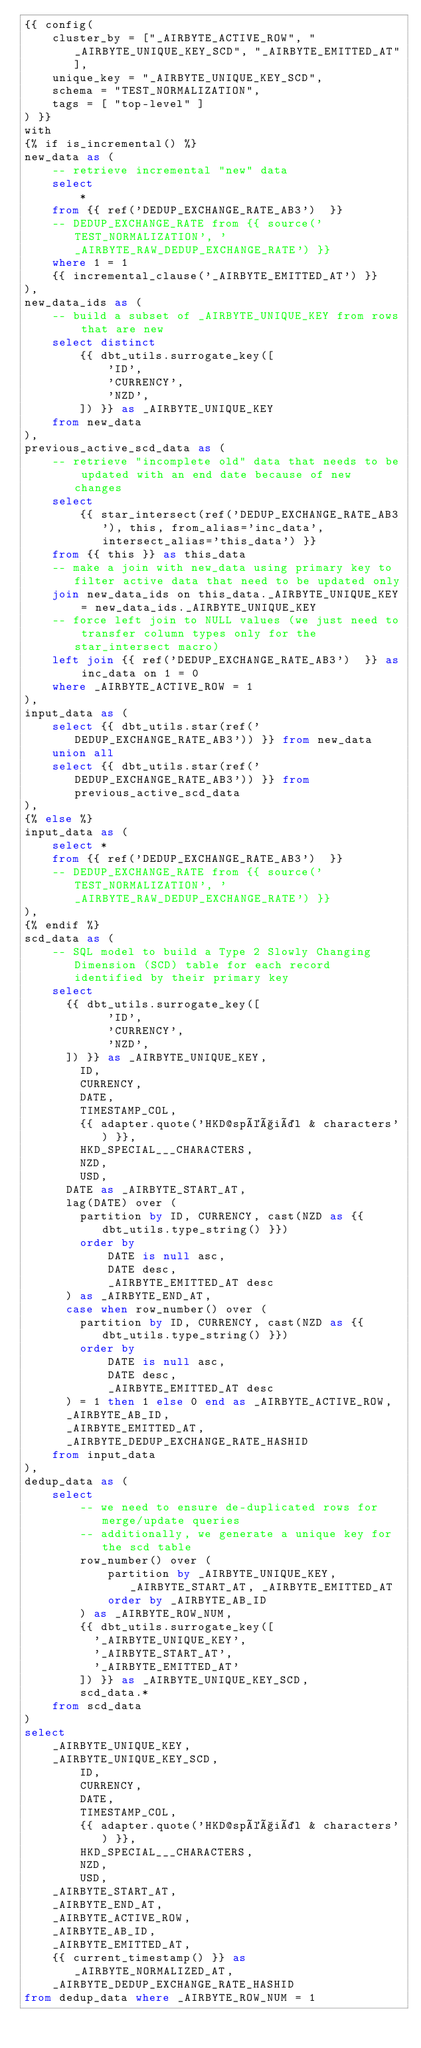<code> <loc_0><loc_0><loc_500><loc_500><_SQL_>{{ config(
    cluster_by = ["_AIRBYTE_ACTIVE_ROW", "_AIRBYTE_UNIQUE_KEY_SCD", "_AIRBYTE_EMITTED_AT"],
    unique_key = "_AIRBYTE_UNIQUE_KEY_SCD",
    schema = "TEST_NORMALIZATION",
    tags = [ "top-level" ]
) }}
with
{% if is_incremental() %}
new_data as (
    -- retrieve incremental "new" data
    select
        *
    from {{ ref('DEDUP_EXCHANGE_RATE_AB3')  }}
    -- DEDUP_EXCHANGE_RATE from {{ source('TEST_NORMALIZATION', '_AIRBYTE_RAW_DEDUP_EXCHANGE_RATE') }}
    where 1 = 1
    {{ incremental_clause('_AIRBYTE_EMITTED_AT') }}
),
new_data_ids as (
    -- build a subset of _AIRBYTE_UNIQUE_KEY from rows that are new
    select distinct
        {{ dbt_utils.surrogate_key([
            'ID',
            'CURRENCY',
            'NZD',
        ]) }} as _AIRBYTE_UNIQUE_KEY
    from new_data
),
previous_active_scd_data as (
    -- retrieve "incomplete old" data that needs to be updated with an end date because of new changes
    select
        {{ star_intersect(ref('DEDUP_EXCHANGE_RATE_AB3'), this, from_alias='inc_data', intersect_alias='this_data') }}
    from {{ this }} as this_data
    -- make a join with new_data using primary key to filter active data that need to be updated only
    join new_data_ids on this_data._AIRBYTE_UNIQUE_KEY = new_data_ids._AIRBYTE_UNIQUE_KEY
    -- force left join to NULL values (we just need to transfer column types only for the star_intersect macro)
    left join {{ ref('DEDUP_EXCHANGE_RATE_AB3')  }} as inc_data on 1 = 0
    where _AIRBYTE_ACTIVE_ROW = 1
),
input_data as (
    select {{ dbt_utils.star(ref('DEDUP_EXCHANGE_RATE_AB3')) }} from new_data
    union all
    select {{ dbt_utils.star(ref('DEDUP_EXCHANGE_RATE_AB3')) }} from previous_active_scd_data
),
{% else %}
input_data as (
    select *
    from {{ ref('DEDUP_EXCHANGE_RATE_AB3')  }}
    -- DEDUP_EXCHANGE_RATE from {{ source('TEST_NORMALIZATION', '_AIRBYTE_RAW_DEDUP_EXCHANGE_RATE') }}
),
{% endif %}
scd_data as (
    -- SQL model to build a Type 2 Slowly Changing Dimension (SCD) table for each record identified by their primary key
    select
      {{ dbt_utils.surrogate_key([
            'ID',
            'CURRENCY',
            'NZD',
      ]) }} as _AIRBYTE_UNIQUE_KEY,
        ID,
        CURRENCY,
        DATE,
        TIMESTAMP_COL,
        {{ adapter.quote('HKD@spéçiäl & characters') }},
        HKD_SPECIAL___CHARACTERS,
        NZD,
        USD,
      DATE as _AIRBYTE_START_AT,
      lag(DATE) over (
        partition by ID, CURRENCY, cast(NZD as {{ dbt_utils.type_string() }})
        order by
            DATE is null asc,
            DATE desc,
            _AIRBYTE_EMITTED_AT desc
      ) as _AIRBYTE_END_AT,
      case when row_number() over (
        partition by ID, CURRENCY, cast(NZD as {{ dbt_utils.type_string() }})
        order by
            DATE is null asc,
            DATE desc,
            _AIRBYTE_EMITTED_AT desc
      ) = 1 then 1 else 0 end as _AIRBYTE_ACTIVE_ROW,
      _AIRBYTE_AB_ID,
      _AIRBYTE_EMITTED_AT,
      _AIRBYTE_DEDUP_EXCHANGE_RATE_HASHID
    from input_data
),
dedup_data as (
    select
        -- we need to ensure de-duplicated rows for merge/update queries
        -- additionally, we generate a unique key for the scd table
        row_number() over (
            partition by _AIRBYTE_UNIQUE_KEY, _AIRBYTE_START_AT, _AIRBYTE_EMITTED_AT
            order by _AIRBYTE_AB_ID
        ) as _AIRBYTE_ROW_NUM,
        {{ dbt_utils.surrogate_key([
          '_AIRBYTE_UNIQUE_KEY',
          '_AIRBYTE_START_AT',
          '_AIRBYTE_EMITTED_AT'
        ]) }} as _AIRBYTE_UNIQUE_KEY_SCD,
        scd_data.*
    from scd_data
)
select
    _AIRBYTE_UNIQUE_KEY,
    _AIRBYTE_UNIQUE_KEY_SCD,
        ID,
        CURRENCY,
        DATE,
        TIMESTAMP_COL,
        {{ adapter.quote('HKD@spéçiäl & characters') }},
        HKD_SPECIAL___CHARACTERS,
        NZD,
        USD,
    _AIRBYTE_START_AT,
    _AIRBYTE_END_AT,
    _AIRBYTE_ACTIVE_ROW,
    _AIRBYTE_AB_ID,
    _AIRBYTE_EMITTED_AT,
    {{ current_timestamp() }} as _AIRBYTE_NORMALIZED_AT,
    _AIRBYTE_DEDUP_EXCHANGE_RATE_HASHID
from dedup_data where _AIRBYTE_ROW_NUM = 1

</code> 